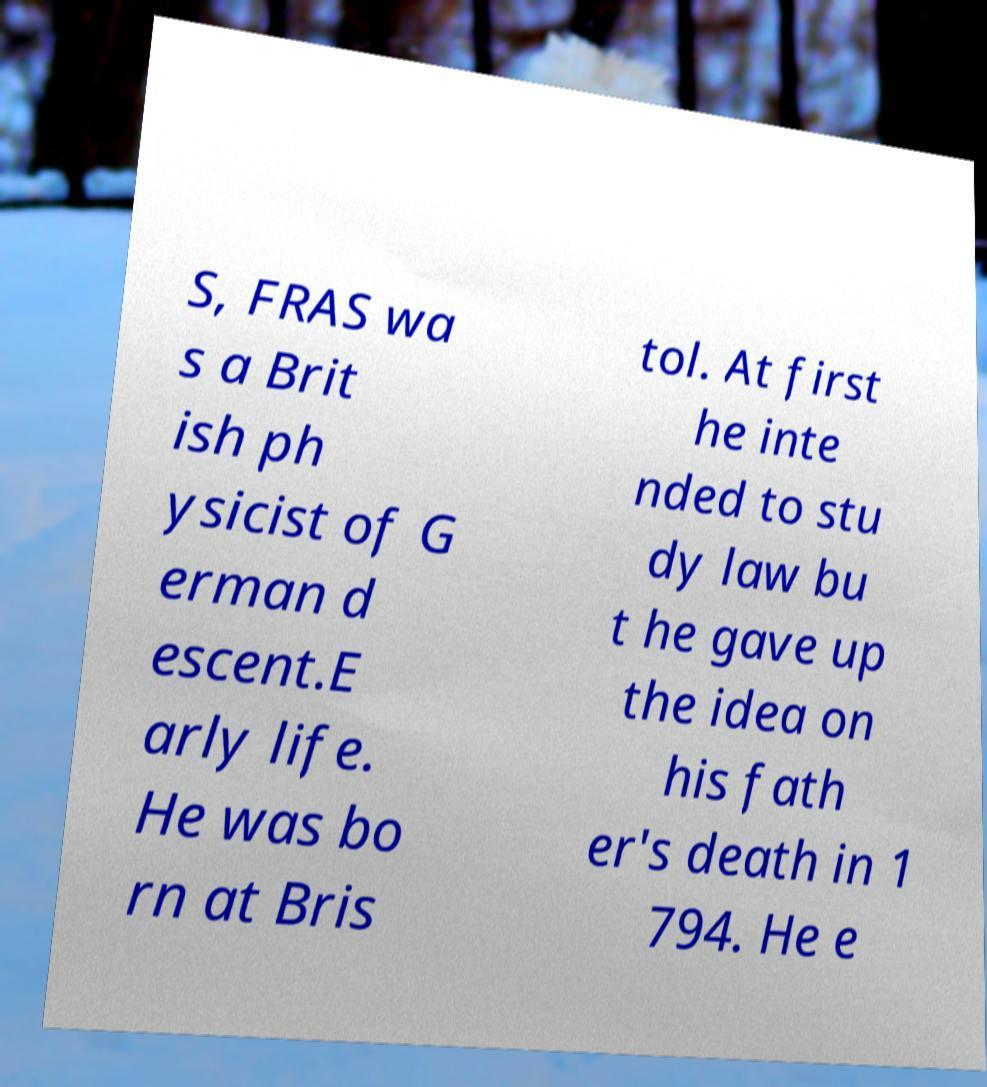I need the written content from this picture converted into text. Can you do that? S, FRAS wa s a Brit ish ph ysicist of G erman d escent.E arly life. He was bo rn at Bris tol. At first he inte nded to stu dy law bu t he gave up the idea on his fath er's death in 1 794. He e 